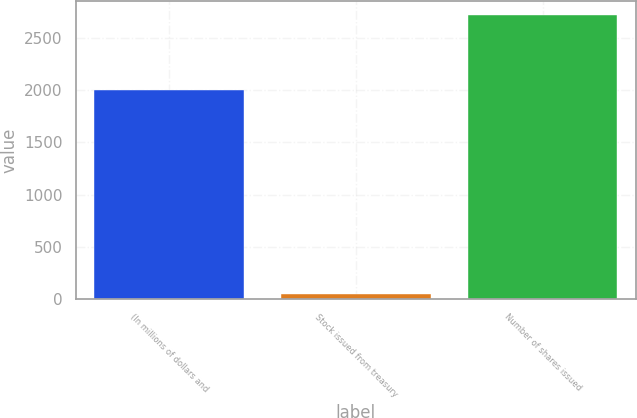Convert chart to OTSL. <chart><loc_0><loc_0><loc_500><loc_500><bar_chart><fcel>(In millions of dollars and<fcel>Stock issued from treasury<fcel>Number of shares issued<nl><fcel>2007<fcel>47<fcel>2723<nl></chart> 